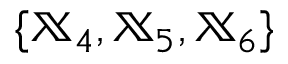Convert formula to latex. <formula><loc_0><loc_0><loc_500><loc_500>\{ { \mathbb { X } } _ { 4 } , { \mathbb { X } } _ { 5 } , { \mathbb { X } } _ { 6 } \}</formula> 